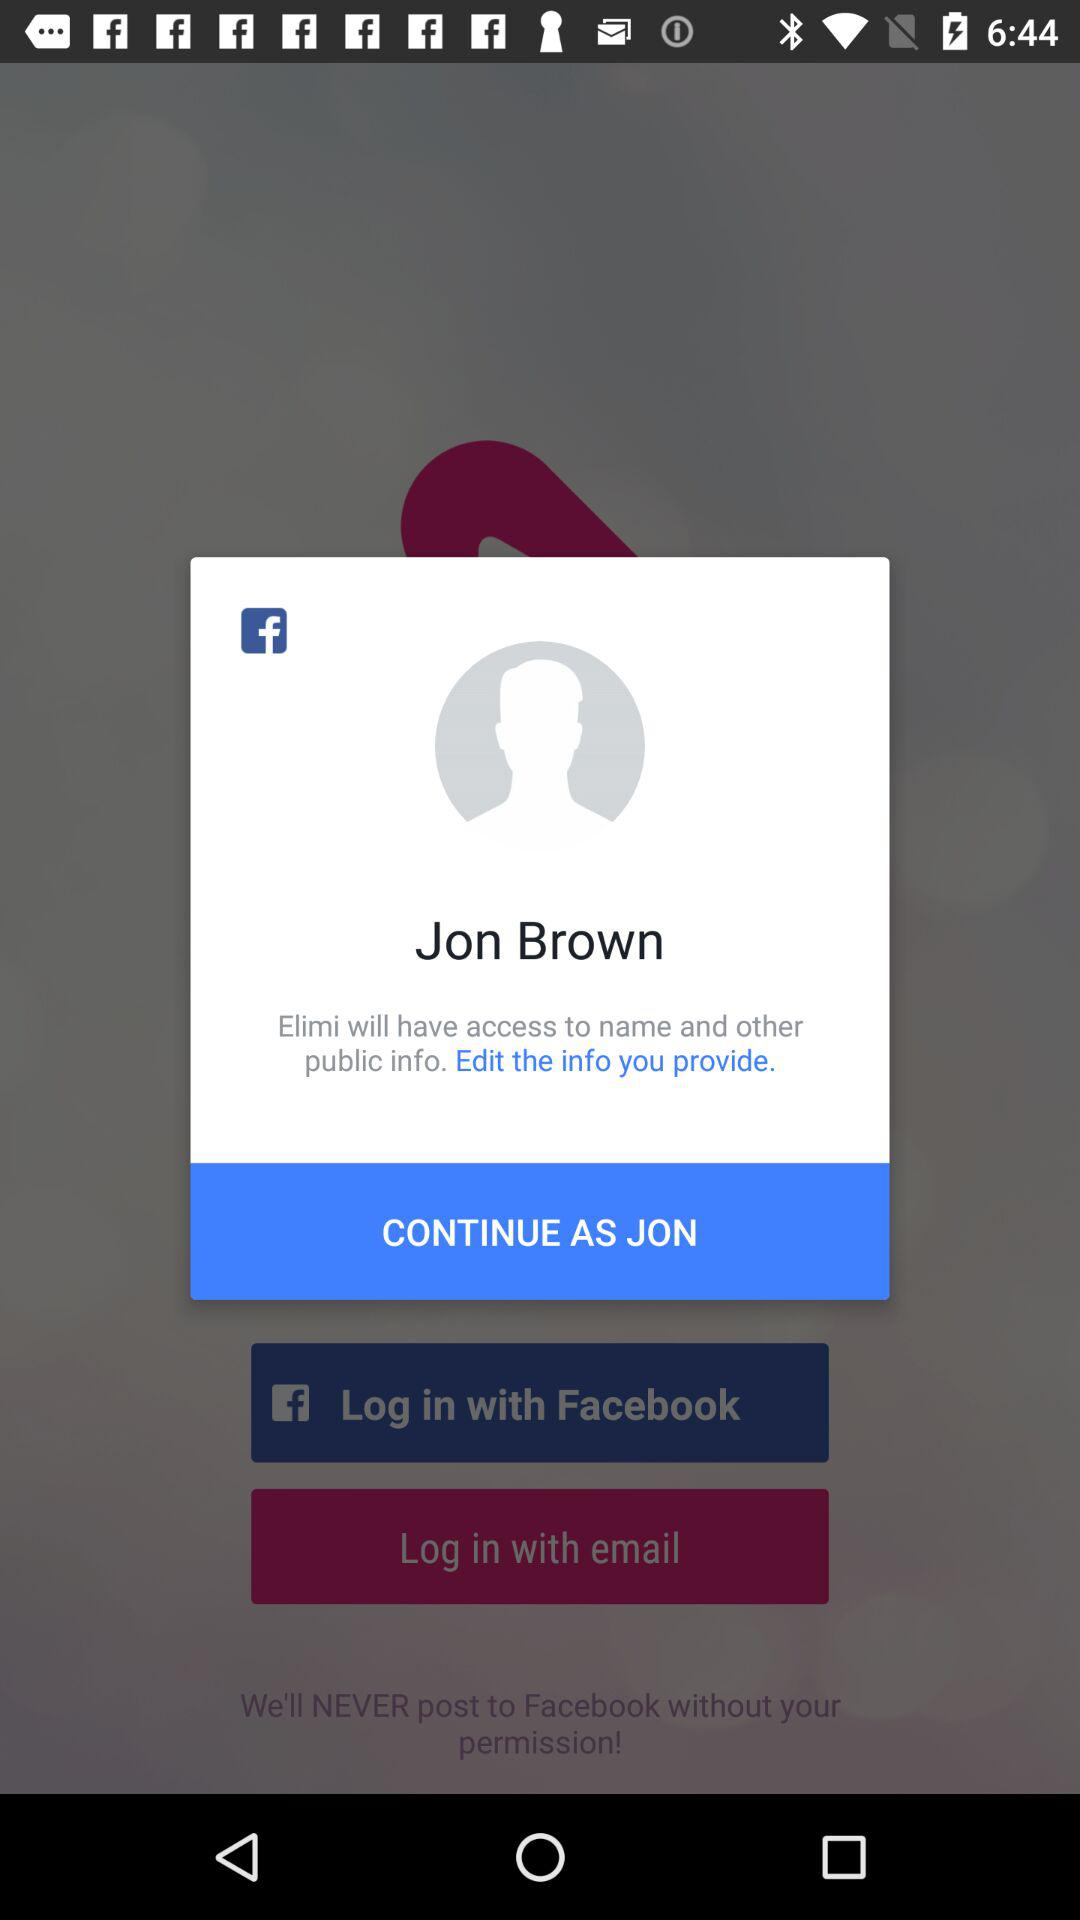What application is asking for permission? The application is "Elimi". 